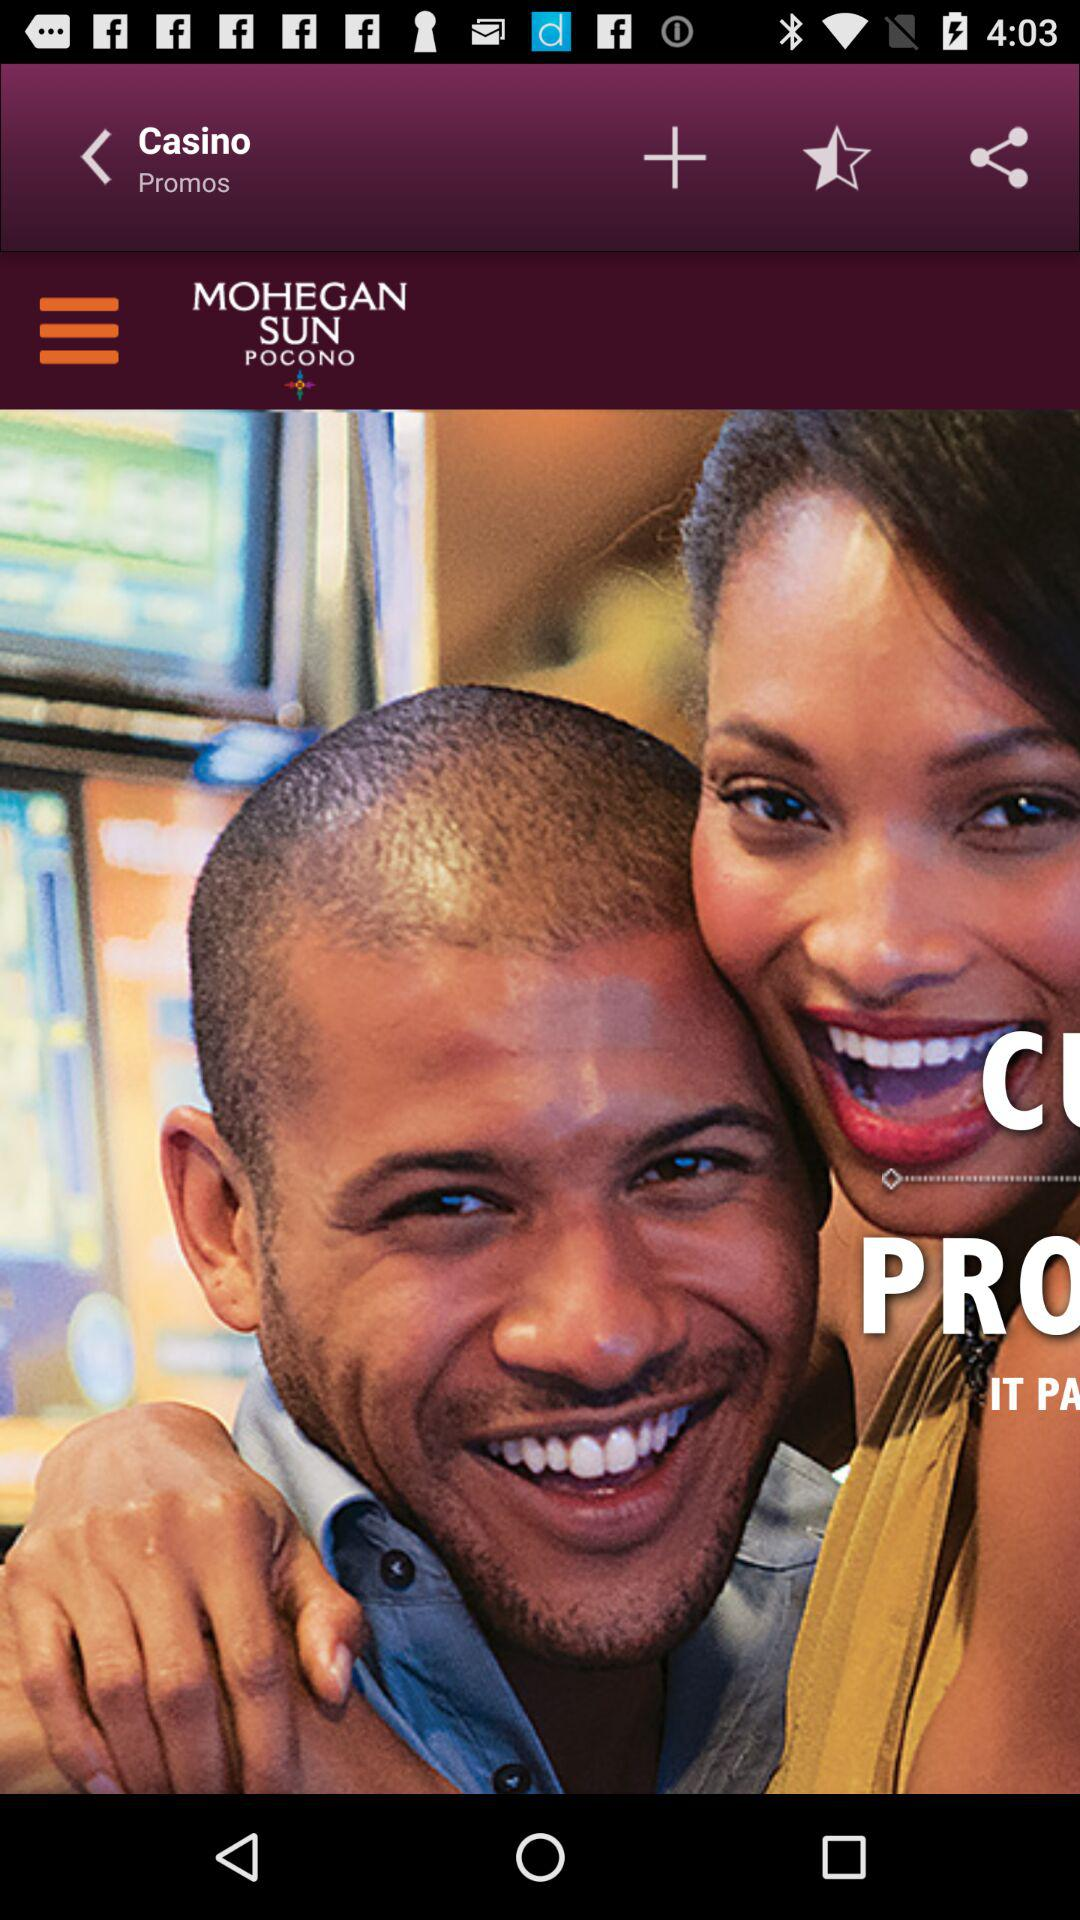What is the application name? The application name is "Casino". 